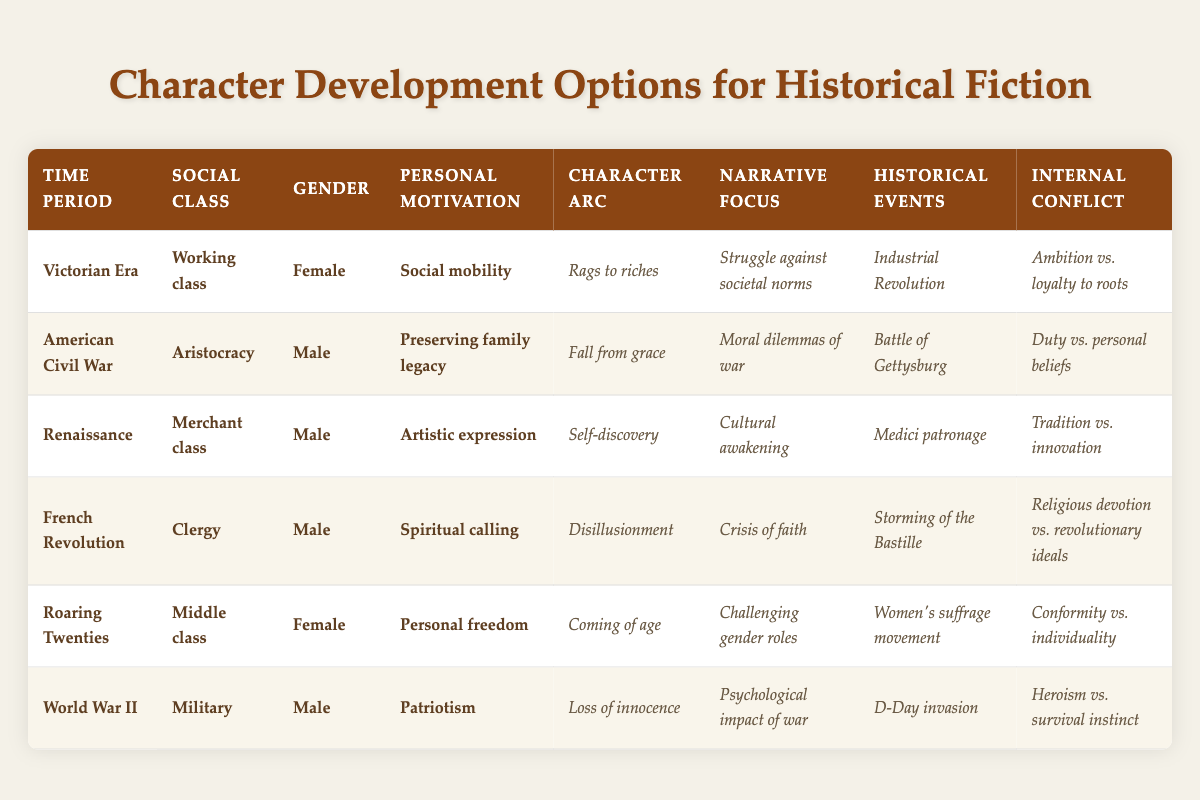What is the character arc for a female working-class protagonist in the Victorian Era? From the table, the character arc for a female working-class protagonist in the Victorian Era focuses on "Rags to riches." This means that the character's journey involves rising from humble beginnings to achieve greater social standing or wealth.
Answer: Rags to riches Which social class does the male protagonist in the American Civil War belong to? Looking at the table, the male protagonist in the American Civil War is classified as belonging to the "Aristocracy." This indicates that he is part of the upper social class during that time.
Answer: Aristocracy True or false: The protagonist’s internal conflict in the Roaring Twenties relates to conformity versus individuality. By checking the respective row for the Roaring Twenties, the internal conflict stated for the female character is "Conformity vs. individuality." Therefore, this statement is true.
Answer: True What are the historical events incorporated in the character arc of the male clergy during the French Revolution? Referring to the specific row for the male clergy during the French Revolution, the table indicates that the historical events to incorporate are the "Storming of the Bastille." This significant event marked the beginning of the revolution.
Answer: Storming of the Bastille How is the narrative focus different between the Victorian Era and the Renaissance? The narrative focus for the Victorian Era (female working class) is "Struggle against societal norms," while for the Renaissance (male merchant class), it is "Cultural awakening." Thus, the focus differs where one addresses societal struggles while the other centers on cultural development.
Answer: Different themes: struggle vs. awakening 